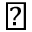Convert formula to latex. <formula><loc_0><loc_0><loc_500><loc_500>\blacktriangledown</formula> 